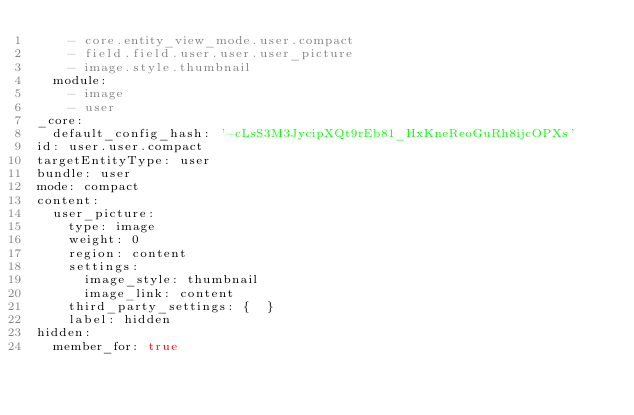Convert code to text. <code><loc_0><loc_0><loc_500><loc_500><_YAML_>    - core.entity_view_mode.user.compact
    - field.field.user.user.user_picture
    - image.style.thumbnail
  module:
    - image
    - user
_core:
  default_config_hash: '-cLsS3M3JycipXQt9rEb81_HxKneReoGuRh8ijcOPXs'
id: user.user.compact
targetEntityType: user
bundle: user
mode: compact
content:
  user_picture:
    type: image
    weight: 0
    region: content
    settings:
      image_style: thumbnail
      image_link: content
    third_party_settings: {  }
    label: hidden
hidden:
  member_for: true
</code> 